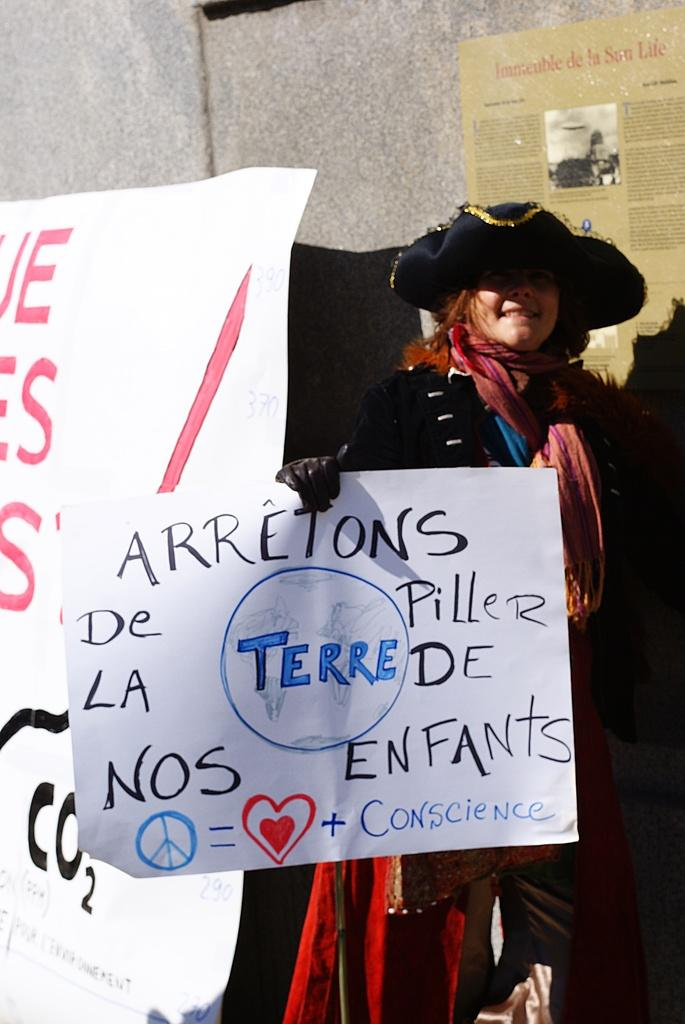Who is present in the image? There is a woman in the image. What is the woman holding in the image? The woman is holding a poster. What can be seen on the poster? There is writing on the poster. What can be seen in the background of the image? There is a banner and a wall in the background of the image. Are there any other posters visible in the image? Yes, there is another poster in the background of the image. What type of zinc is being used to celebrate the birthday in the image? There is no zinc or birthday celebration present in the image. What type of hospital is visible in the background of the image? There is no hospital visible in the image; it features a woman holding a poster with writing on it, a banner, and a wall in the background. 